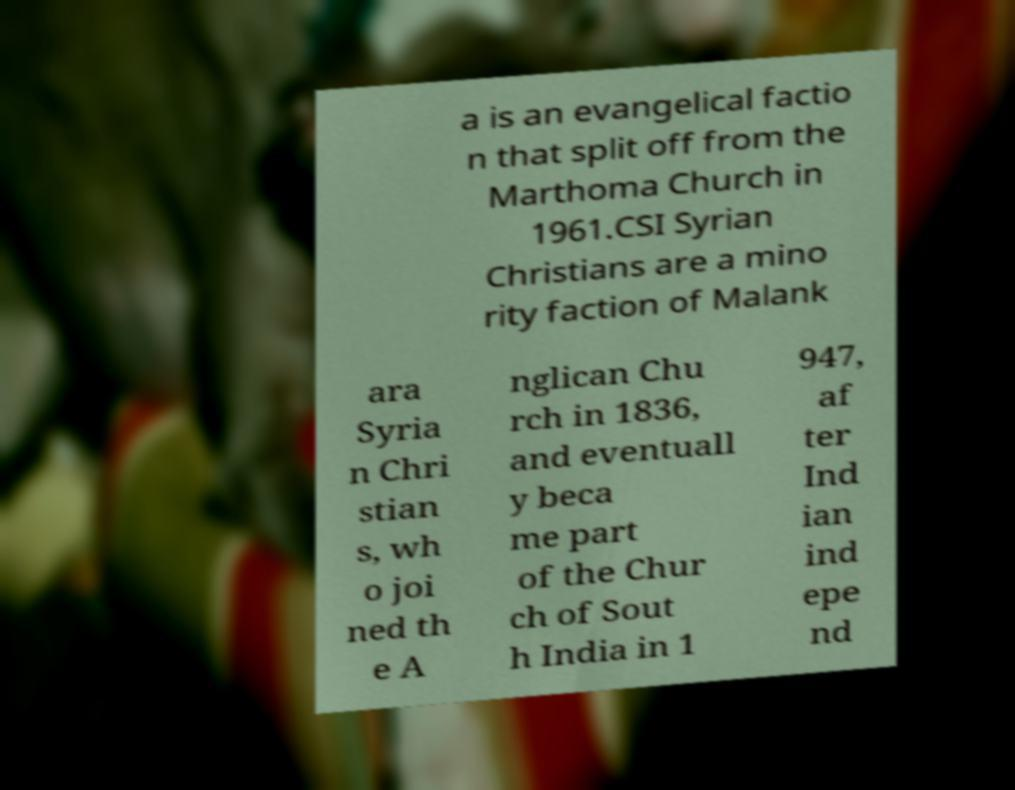For documentation purposes, I need the text within this image transcribed. Could you provide that? a is an evangelical factio n that split off from the Marthoma Church in 1961.CSI Syrian Christians are a mino rity faction of Malank ara Syria n Chri stian s, wh o joi ned th e A nglican Chu rch in 1836, and eventuall y beca me part of the Chur ch of Sout h India in 1 947, af ter Ind ian ind epe nd 